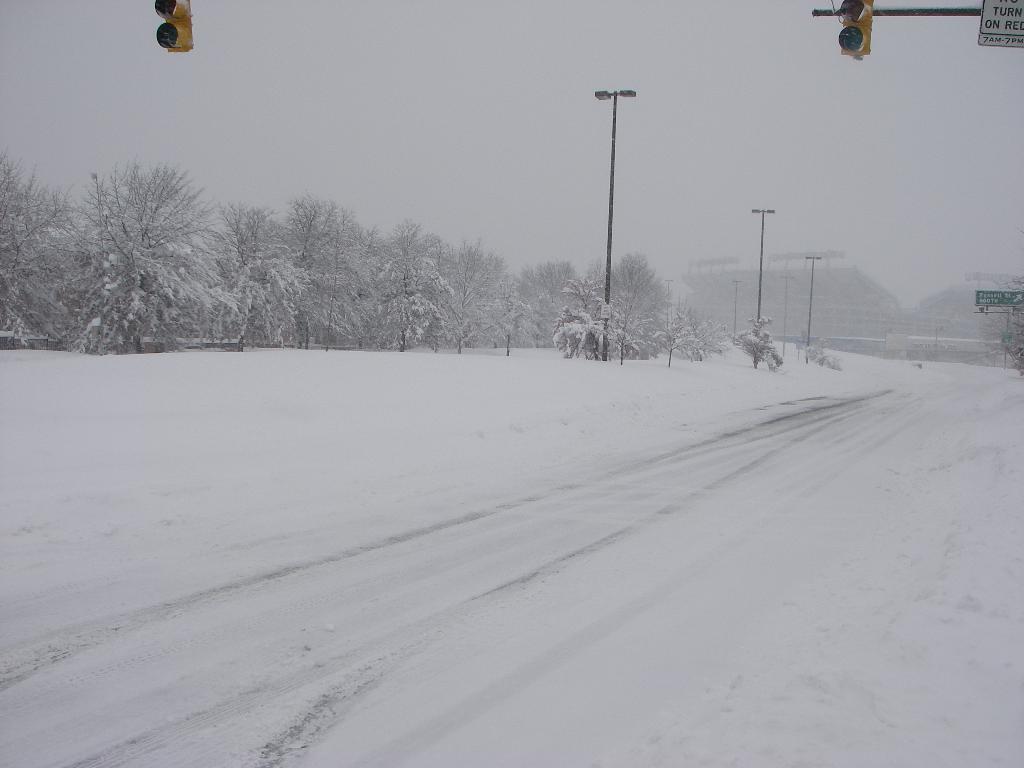Describe this image in one or two sentences. In this image we can see snow on the road. In the background of the image there are trees, poles. To the right side of the image there is a directional board. At the top of the image there are signal lights. 